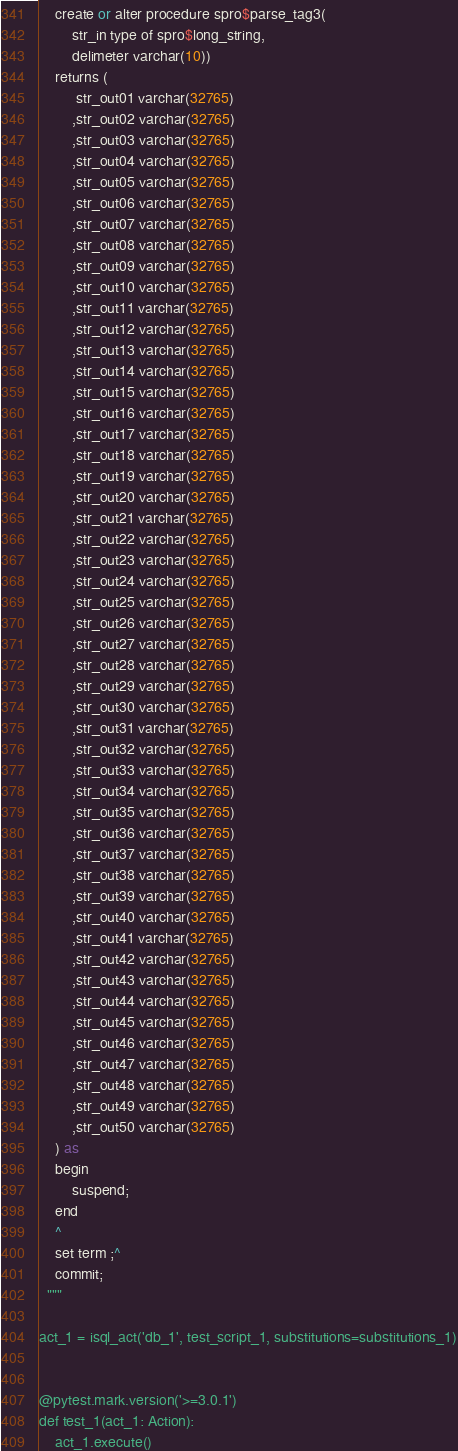<code> <loc_0><loc_0><loc_500><loc_500><_Python_>    create or alter procedure spro$parse_tag3(
        str_in type of spro$long_string,
        delimeter varchar(10))
    returns (
         str_out01 varchar(32765)
        ,str_out02 varchar(32765)
        ,str_out03 varchar(32765)
        ,str_out04 varchar(32765)
        ,str_out05 varchar(32765)
        ,str_out06 varchar(32765)
        ,str_out07 varchar(32765)
        ,str_out08 varchar(32765)
        ,str_out09 varchar(32765)
        ,str_out10 varchar(32765)
        ,str_out11 varchar(32765)
        ,str_out12 varchar(32765)
        ,str_out13 varchar(32765)
        ,str_out14 varchar(32765)
        ,str_out15 varchar(32765)
        ,str_out16 varchar(32765)
        ,str_out17 varchar(32765)
        ,str_out18 varchar(32765)
        ,str_out19 varchar(32765)
        ,str_out20 varchar(32765)
        ,str_out21 varchar(32765)
        ,str_out22 varchar(32765)
        ,str_out23 varchar(32765)
        ,str_out24 varchar(32765)
        ,str_out25 varchar(32765)
        ,str_out26 varchar(32765)
        ,str_out27 varchar(32765)
        ,str_out28 varchar(32765)
        ,str_out29 varchar(32765)
        ,str_out30 varchar(32765)
        ,str_out31 varchar(32765)
        ,str_out32 varchar(32765)
        ,str_out33 varchar(32765)
        ,str_out34 varchar(32765)
        ,str_out35 varchar(32765)
        ,str_out36 varchar(32765)
        ,str_out37 varchar(32765)
        ,str_out38 varchar(32765)
        ,str_out39 varchar(32765)
        ,str_out40 varchar(32765)
        ,str_out41 varchar(32765)
        ,str_out42 varchar(32765)
        ,str_out43 varchar(32765)
        ,str_out44 varchar(32765)
        ,str_out45 varchar(32765)
        ,str_out46 varchar(32765)
        ,str_out47 varchar(32765)
        ,str_out48 varchar(32765)
        ,str_out49 varchar(32765)
        ,str_out50 varchar(32765)
    ) as 
    begin
        suspend;
    end
    ^
    set term ;^
    commit;
  """

act_1 = isql_act('db_1', test_script_1, substitutions=substitutions_1)


@pytest.mark.version('>=3.0.1')
def test_1(act_1: Action):
    act_1.execute()

</code> 